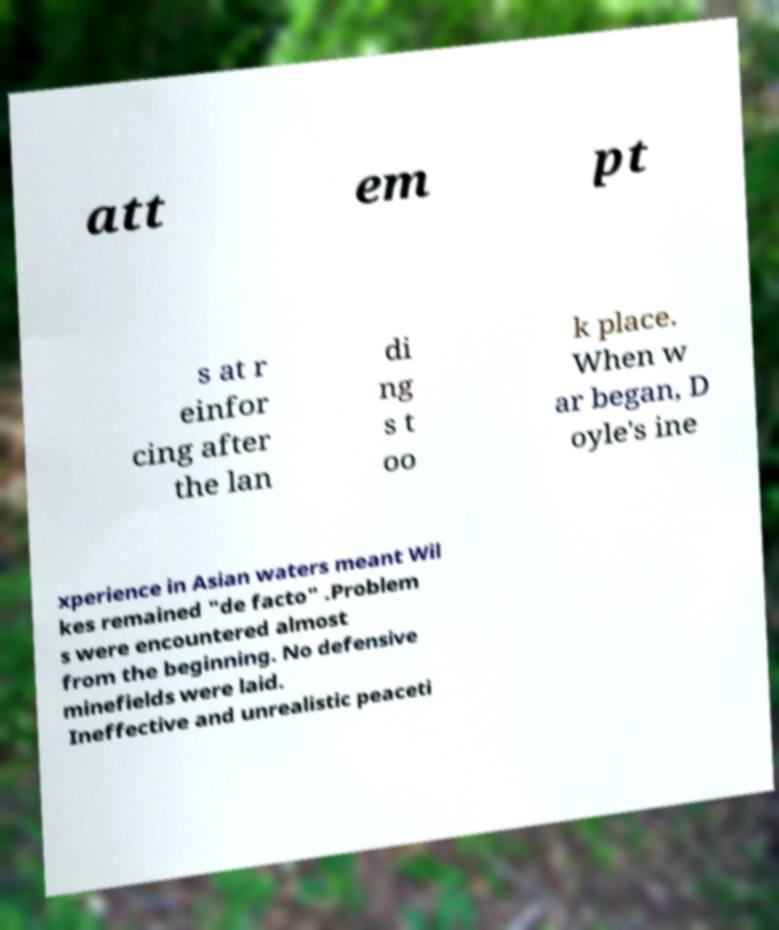Could you extract and type out the text from this image? att em pt s at r einfor cing after the lan di ng s t oo k place. When w ar began, D oyle's ine xperience in Asian waters meant Wil kes remained "de facto" .Problem s were encountered almost from the beginning. No defensive minefields were laid. Ineffective and unrealistic peaceti 